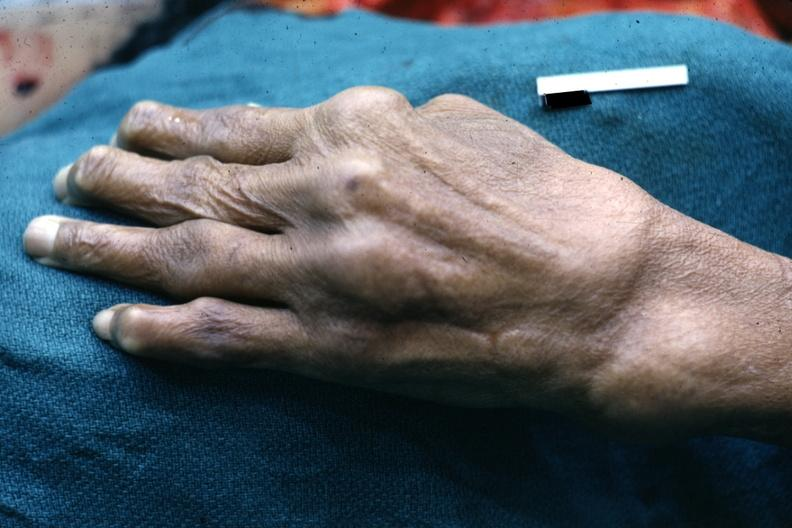s hand present?
Answer the question using a single word or phrase. Yes 